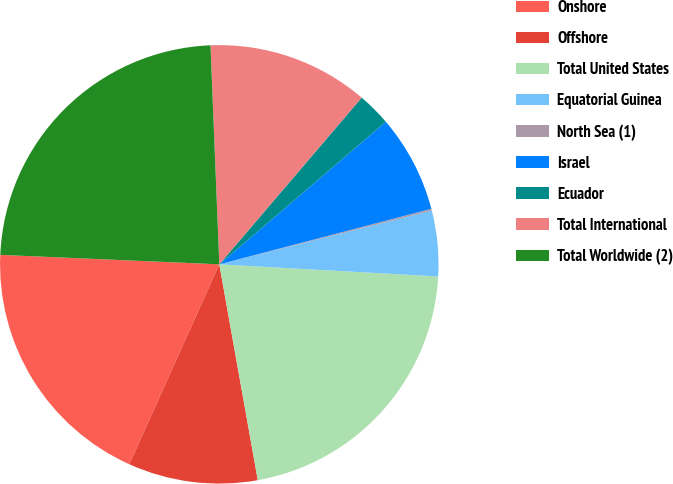Convert chart to OTSL. <chart><loc_0><loc_0><loc_500><loc_500><pie_chart><fcel>Onshore<fcel>Offshore<fcel>Total United States<fcel>Equatorial Guinea<fcel>North Sea (1)<fcel>Israel<fcel>Ecuador<fcel>Total International<fcel>Total Worldwide (2)<nl><fcel>18.96%<fcel>9.54%<fcel>21.31%<fcel>4.83%<fcel>0.13%<fcel>7.19%<fcel>2.48%<fcel>11.89%<fcel>23.67%<nl></chart> 